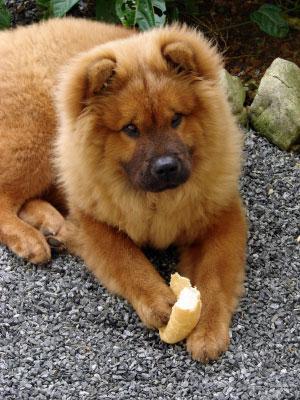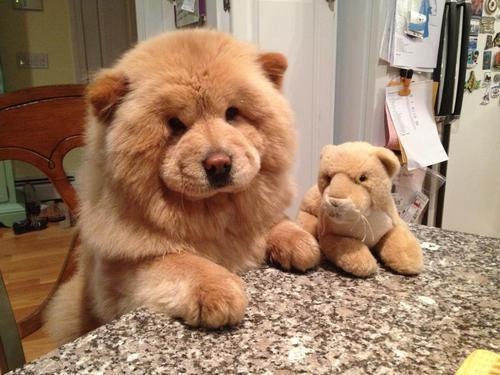The first image is the image on the left, the second image is the image on the right. Evaluate the accuracy of this statement regarding the images: "One of the images contains a dog that is laying down.". Is it true? Answer yes or no. Yes. 